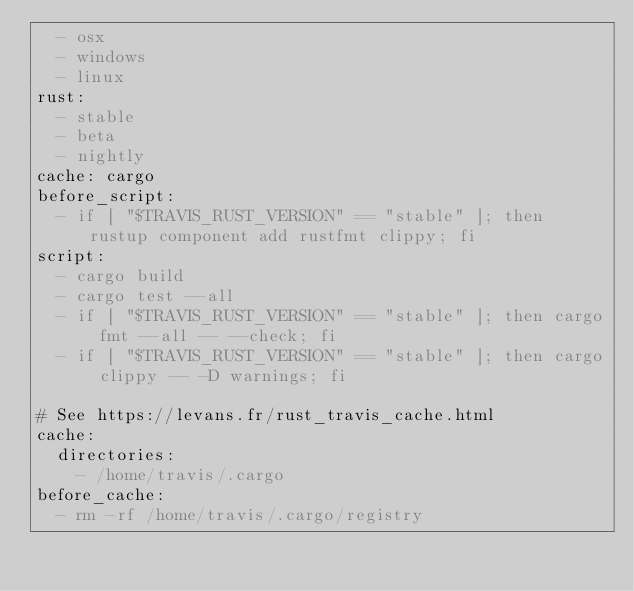Convert code to text. <code><loc_0><loc_0><loc_500><loc_500><_YAML_>  - osx
  - windows
  - linux
rust:
  - stable
  - beta
  - nightly
cache: cargo
before_script:
  - if [ "$TRAVIS_RUST_VERSION" == "stable" ]; then rustup component add rustfmt clippy; fi
script:
  - cargo build
  - cargo test --all
  - if [ "$TRAVIS_RUST_VERSION" == "stable" ]; then cargo fmt --all -- --check; fi
  - if [ "$TRAVIS_RUST_VERSION" == "stable" ]; then cargo clippy -- -D warnings; fi

# See https://levans.fr/rust_travis_cache.html
cache:
  directories:
    - /home/travis/.cargo
before_cache:
  - rm -rf /home/travis/.cargo/registry

</code> 